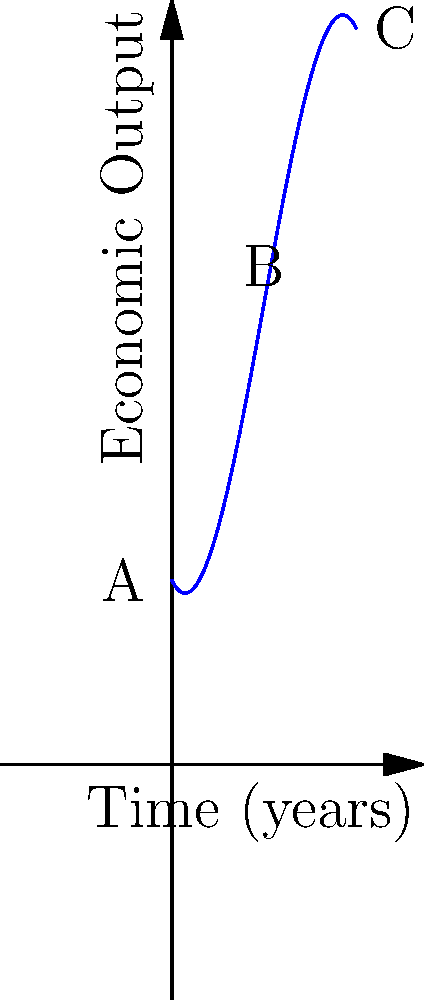In a fantasy realm, a new magical technology is introduced that initially boosts economic output but eventually leads to diminishing returns. The polynomial function $f(x) = -0.1x^3 + 1.5x^2 - 2x + 10$ represents the economic output over time, where $x$ is the number of years since the technology's introduction. At what point (in years) does the economic output reach its maximum? To find the maximum point of the economic output, we need to follow these steps:

1) The maximum point occurs where the derivative of the function equals zero. Let's find the derivative:

   $f'(x) = -0.3x^2 + 3x - 2$

2) Set the derivative equal to zero and solve for x:

   $-0.3x^2 + 3x - 2 = 0$

3) This is a quadratic equation. We can solve it using the quadratic formula:
   $x = \frac{-b \pm \sqrt{b^2 - 4ac}}{2a}$

   Where $a = -0.3$, $b = 3$, and $c = -2$

4) Plugging these values into the quadratic formula:

   $x = \frac{-3 \pm \sqrt{3^2 - 4(-0.3)(-2)}}{2(-0.3)}$

5) Simplifying:

   $x = \frac{-3 \pm \sqrt{9 - 2.4}}{-0.6} = \frac{-3 \pm \sqrt{6.6}}{-0.6}$

6) This gives us two solutions:

   $x_1 \approx 1.37$ and $x_2 \approx 8.63$

7) Since we're looking for the maximum point, and the coefficient of $x^3$ in the original function is negative (indicating the function eventually decreases), the maximum occurs at the larger x-value.

Therefore, the economic output reaches its maximum after approximately 8.63 years.
Answer: 8.63 years 